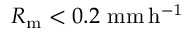Convert formula to latex. <formula><loc_0><loc_0><loc_500><loc_500>R _ { m } < 0 . 2 \ m m \, h ^ { - 1 }</formula> 